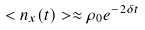Convert formula to latex. <formula><loc_0><loc_0><loc_500><loc_500>< n _ { x } ( t ) > \approx \rho _ { 0 } e ^ { - 2 \delta t }</formula> 